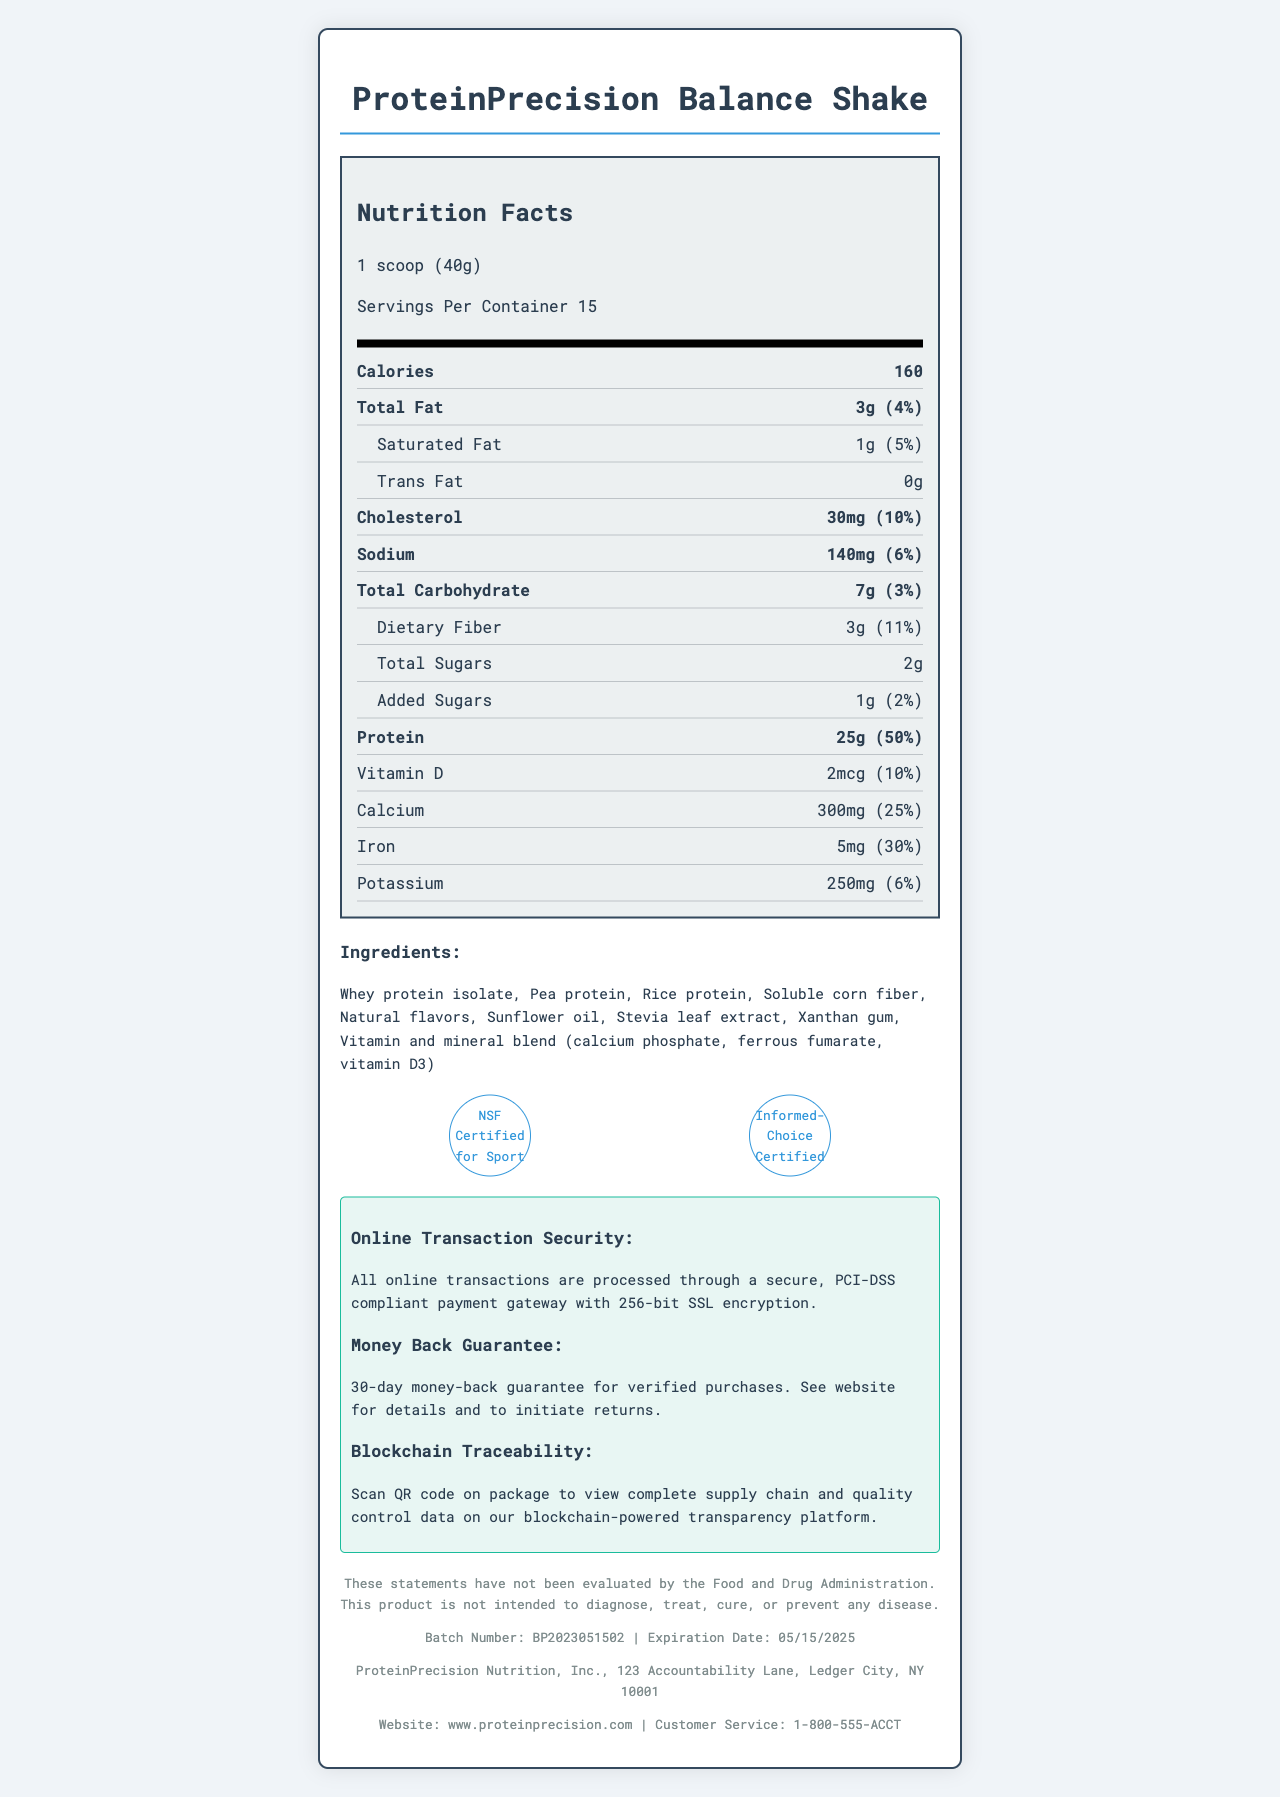what is the serving size of the ProteinPrecision Balance Shake? The serving size is mentioned in the nutrition facts section of the document as 1 scoop (40g).
Answer: 1 scoop (40g) how many servings are there per container? The document states that there are 15 servings per container.
Answer: 15 how many grams of protein does one serving contain? The nutrition facts label states that one serving contains 25g of protein.
Answer: 25g what is the total amount of carbohydrates per serving? The total carbohydrate content per serving is listed as 7g in the nutrition facts.
Answer: 7g how much dietary fiber is included in one serving? The amount of dietary fiber per serving is mentioned as 3g.
Answer: 3g which certification does the product have? A. USDA Organic B. Informed-Choice Certified C. Keto Certified D. Fair Trade The document lists "Informed-Choice Certified" as one of the certifications.
Answer: B what percentage of the daily value of Iron does one serving of the shake provide? A. 10% B. 25% C. 30% D. 50% The daily value of Iron per serving is listed as 30%, which corresponds to option C.
Answer: C does the product contain any trans fat? The nutrition facts label specifies that the product contains 0g of trans fat.
Answer: No please summarize the main idea of the document. This explanation summarizes the key features and details presented throughout the document.
Answer: The document provides a detailed overview of the nutritional information, ingredients, and certifications of the ProteinPrecision Balance Shake, a high-protein meal replacement shake. It also includes information about the product's serving size, online transaction security, preparation and storage instructions, and contact details for the manufacturer. what type of protein is included in the shake? The document lists the types of proteins such as Whey protein isolate, Pea protein, and Rice protein, but does not specify the proportion or types in detail beyond these names.
Answer: Cannot be determined 